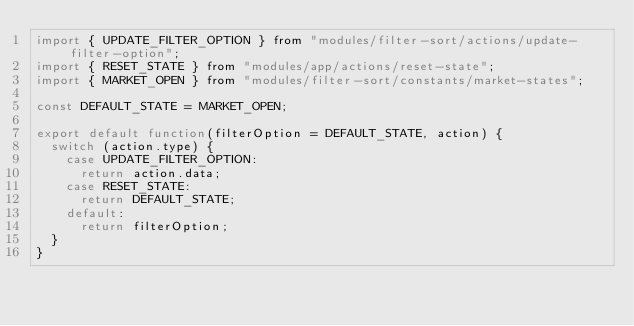Convert code to text. <code><loc_0><loc_0><loc_500><loc_500><_JavaScript_>import { UPDATE_FILTER_OPTION } from "modules/filter-sort/actions/update-filter-option";
import { RESET_STATE } from "modules/app/actions/reset-state";
import { MARKET_OPEN } from "modules/filter-sort/constants/market-states";

const DEFAULT_STATE = MARKET_OPEN;

export default function(filterOption = DEFAULT_STATE, action) {
  switch (action.type) {
    case UPDATE_FILTER_OPTION:
      return action.data;
    case RESET_STATE:
      return DEFAULT_STATE;
    default:
      return filterOption;
  }
}
</code> 